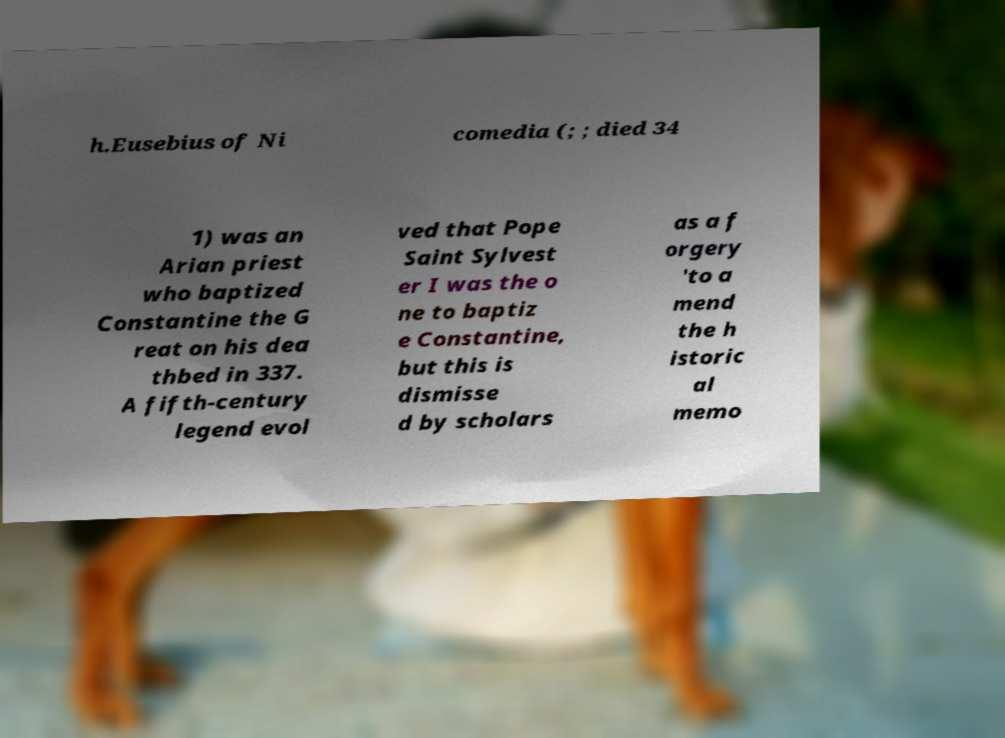Can you read and provide the text displayed in the image?This photo seems to have some interesting text. Can you extract and type it out for me? h.Eusebius of Ni comedia (; ; died 34 1) was an Arian priest who baptized Constantine the G reat on his dea thbed in 337. A fifth-century legend evol ved that Pope Saint Sylvest er I was the o ne to baptiz e Constantine, but this is dismisse d by scholars as a f orgery 'to a mend the h istoric al memo 